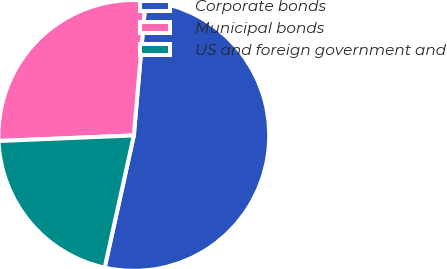Convert chart to OTSL. <chart><loc_0><loc_0><loc_500><loc_500><pie_chart><fcel>Corporate bonds<fcel>Municipal bonds<fcel>US and foreign government and<nl><fcel>52.07%<fcel>27.04%<fcel>20.89%<nl></chart> 